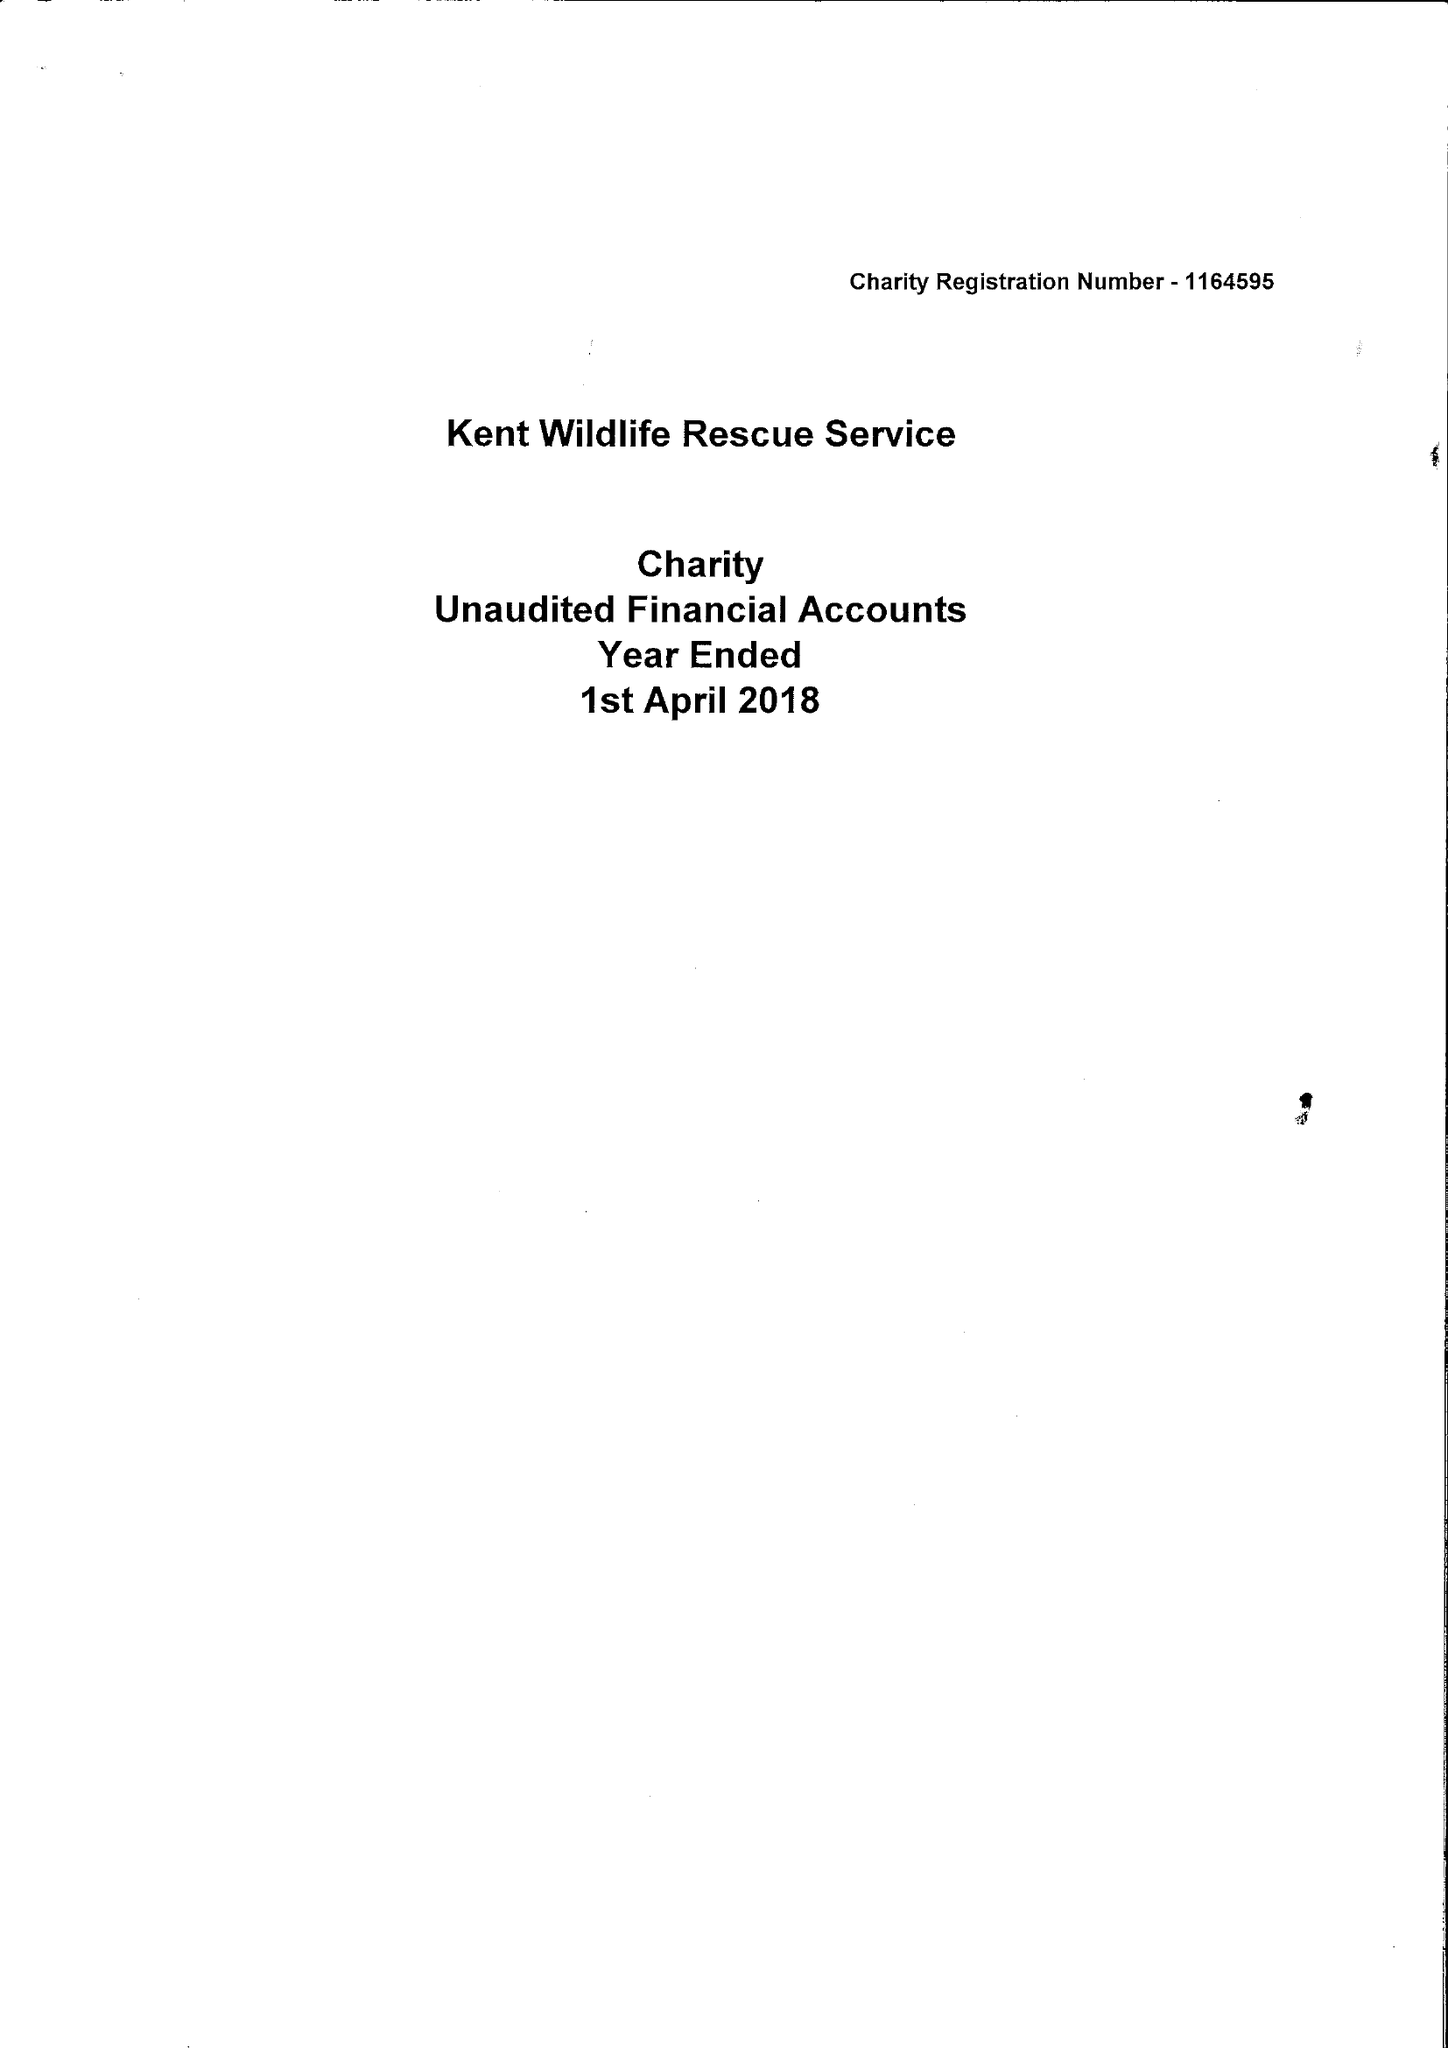What is the value for the income_annually_in_british_pounds?
Answer the question using a single word or phrase. 17135.00 